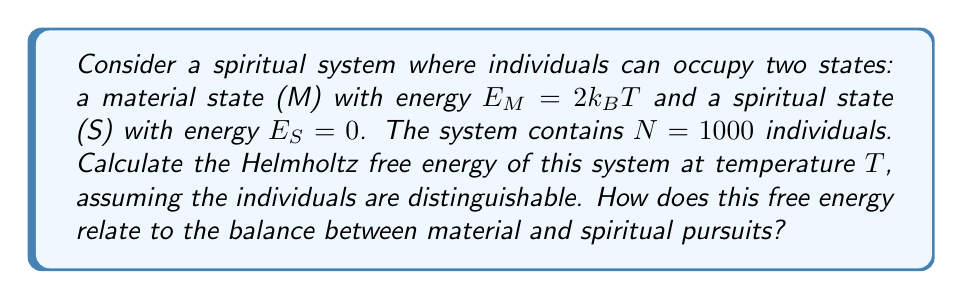Can you answer this question? To solve this problem, we'll follow these steps:

1) First, we need to calculate the partition function $Z$ for a single individual:
   $$Z = e^{-E_M/k_BT} + e^{-E_S/k_BT} = e^{-2} + e^0 = e^{-2} + 1$$

2) Since the individuals are distinguishable, the total partition function for the system is:
   $$Z_{total} = Z^N = (e^{-2} + 1)^{1000}$$

3) The Helmholtz free energy $F$ is given by:
   $$F = -k_BT \ln Z_{total}$$

4) Substituting our $Z_{total}$:
   $$F = -k_BT \ln (e^{-2} + 1)^{1000}$$

5) Using the properties of logarithms:
   $$F = -1000k_BT \ln (e^{-2} + 1)$$

6) We can interpret this result in terms of the balance between material and spiritual pursuits:
   - The term $e^{-2}$ represents the contribution of the material state.
   - The term $1$ represents the contribution of the spiritual state.
   - The lower the free energy, the more favorable the state of the system.
   - The balance between these terms in the logarithm represents the equilibrium between material and spiritual pursuits.

This free energy represents the available energy in the system that can be converted to work, which in this spiritual context could be interpreted as the potential for spiritual growth or material achievement.
Answer: $F = -1000k_BT \ln (e^{-2} + 1)$ 